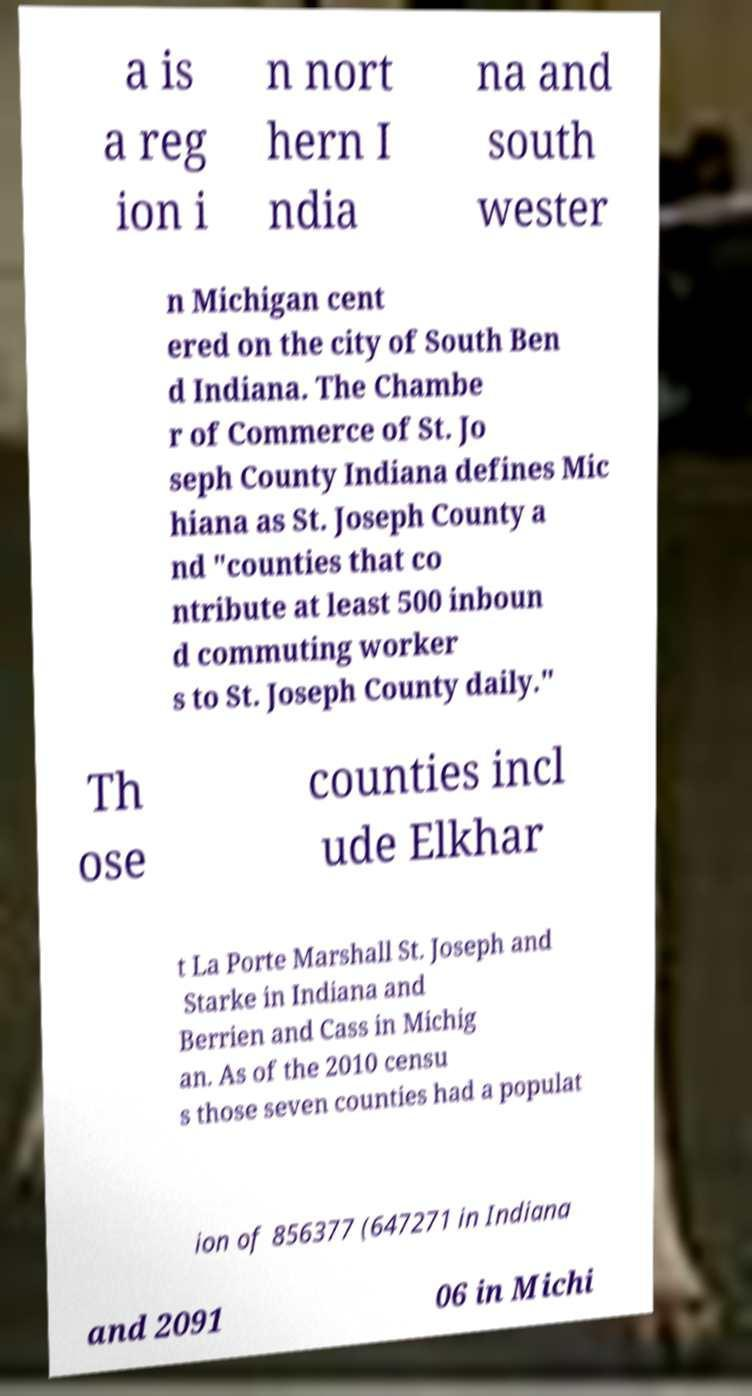There's text embedded in this image that I need extracted. Can you transcribe it verbatim? a is a reg ion i n nort hern I ndia na and south wester n Michigan cent ered on the city of South Ben d Indiana. The Chambe r of Commerce of St. Jo seph County Indiana defines Mic hiana as St. Joseph County a nd "counties that co ntribute at least 500 inboun d commuting worker s to St. Joseph County daily." Th ose counties incl ude Elkhar t La Porte Marshall St. Joseph and Starke in Indiana and Berrien and Cass in Michig an. As of the 2010 censu s those seven counties had a populat ion of 856377 (647271 in Indiana and 2091 06 in Michi 